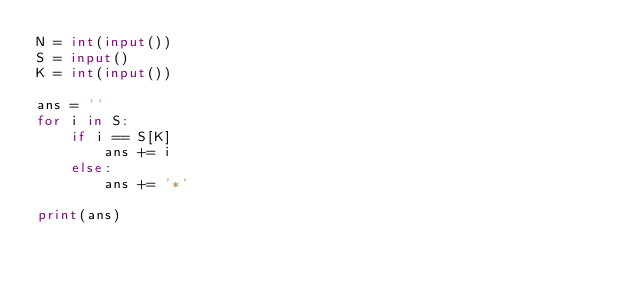Convert code to text. <code><loc_0><loc_0><loc_500><loc_500><_Python_>N = int(input())
S = input()
K = int(input())

ans = ''
for i in S:
    if i == S[K]
        ans += i
    else:
        ans += '*'

print(ans)</code> 